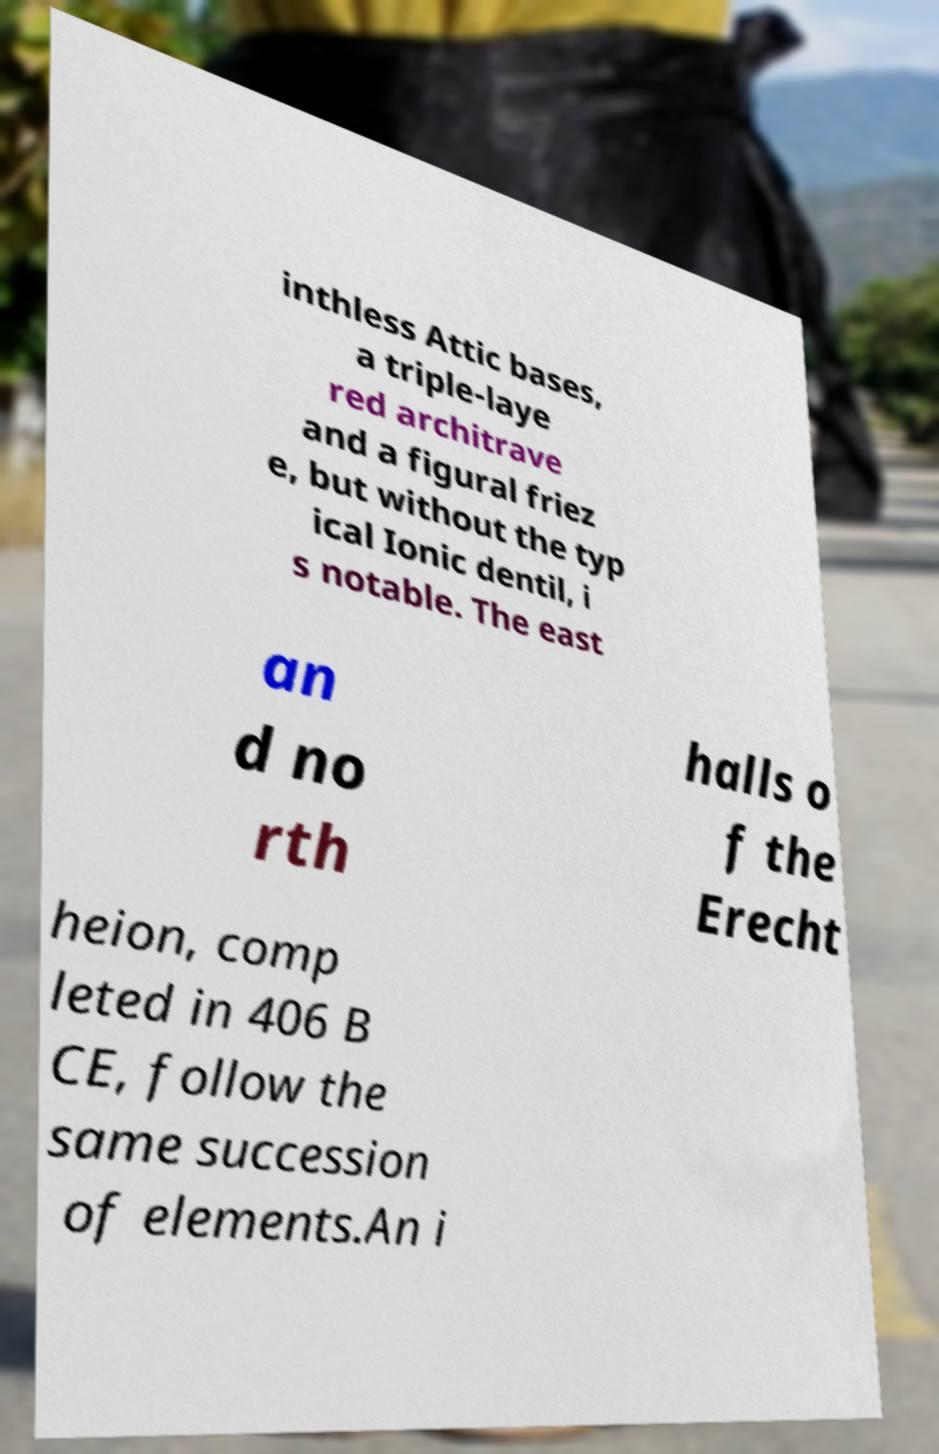Could you assist in decoding the text presented in this image and type it out clearly? inthless Attic bases, a triple-laye red architrave and a figural friez e, but without the typ ical Ionic dentil, i s notable. The east an d no rth halls o f the Erecht heion, comp leted in 406 B CE, follow the same succession of elements.An i 